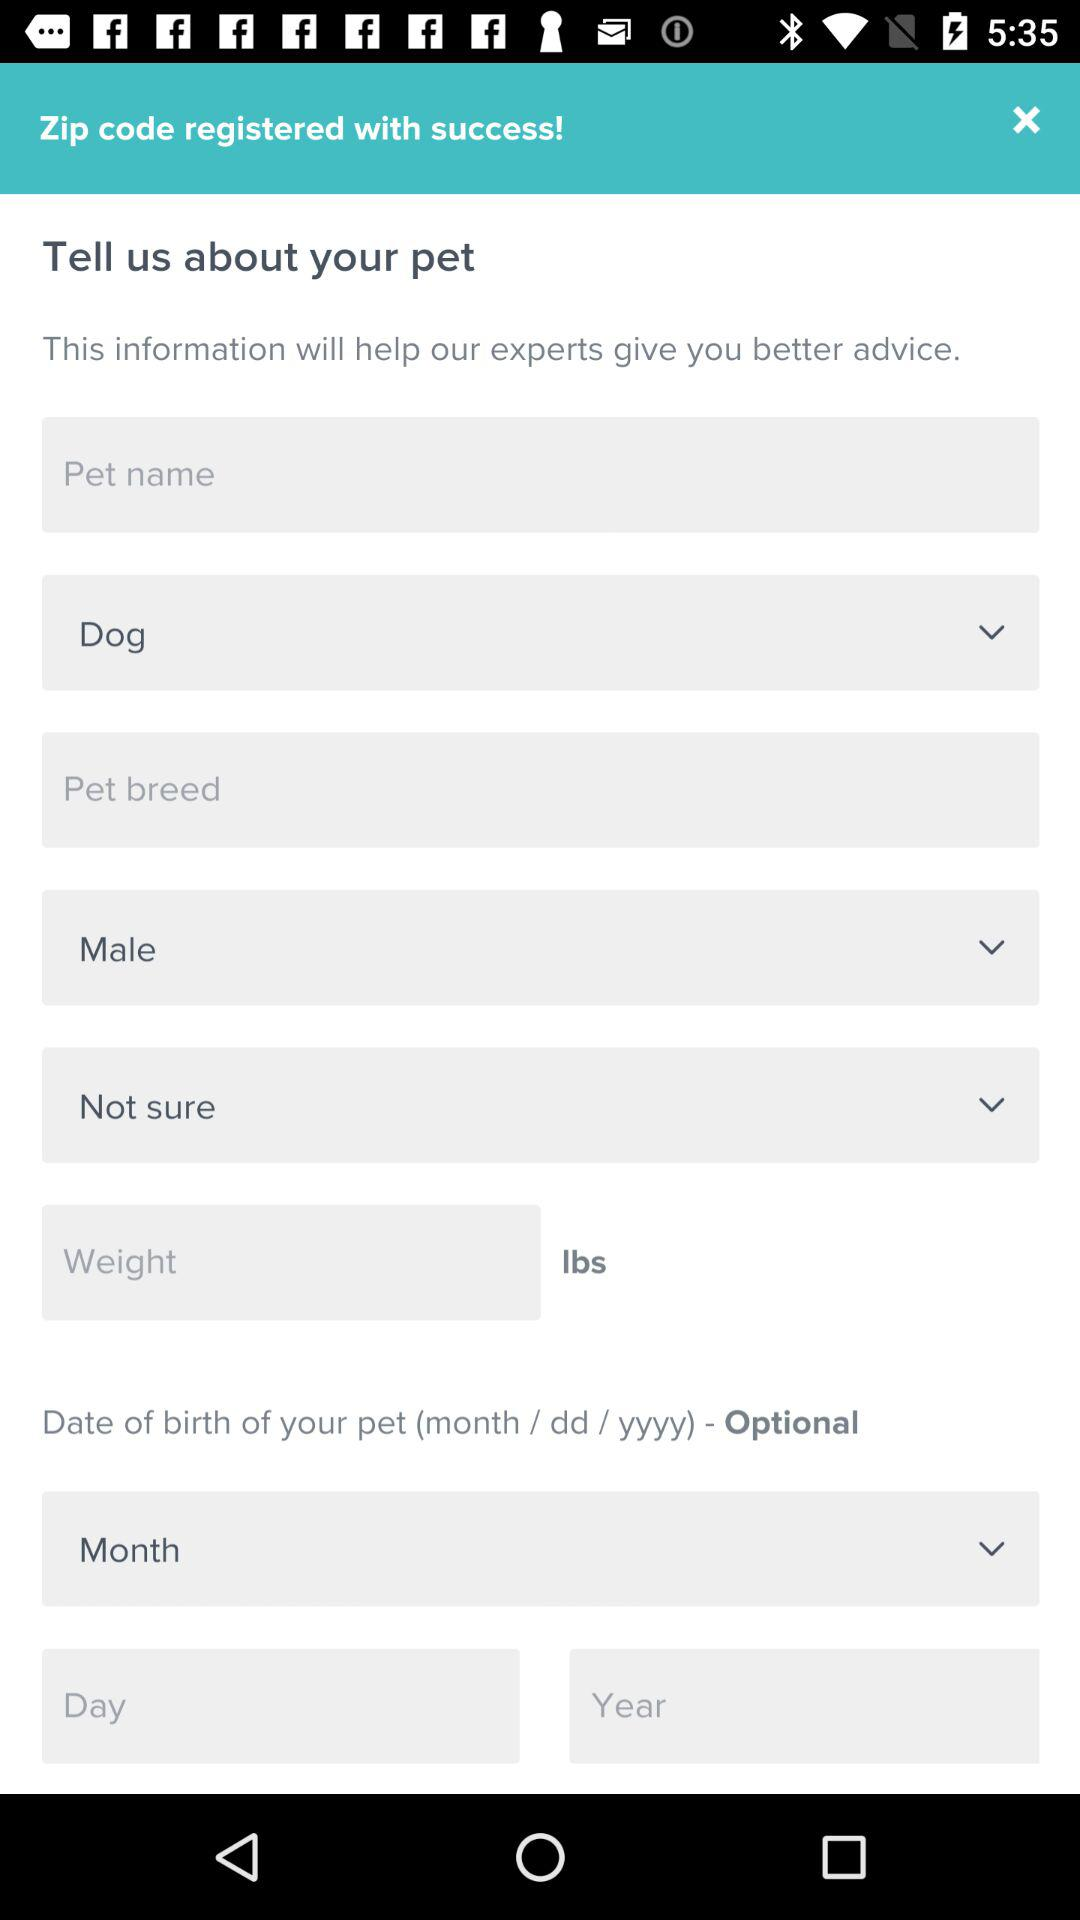How many input fields are there for pet's gender?
Answer the question using a single word or phrase. 2 